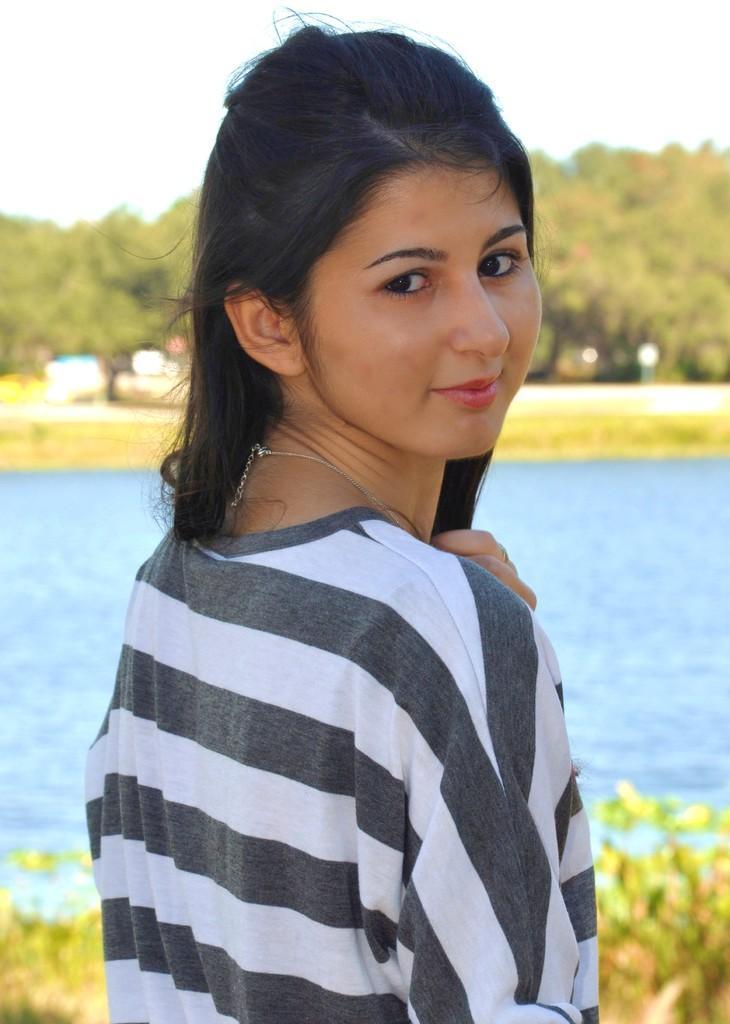How would you summarize this image in a sentence or two? There is a woman smiling. We can see plants and water. In the background we can see trees and sky. 